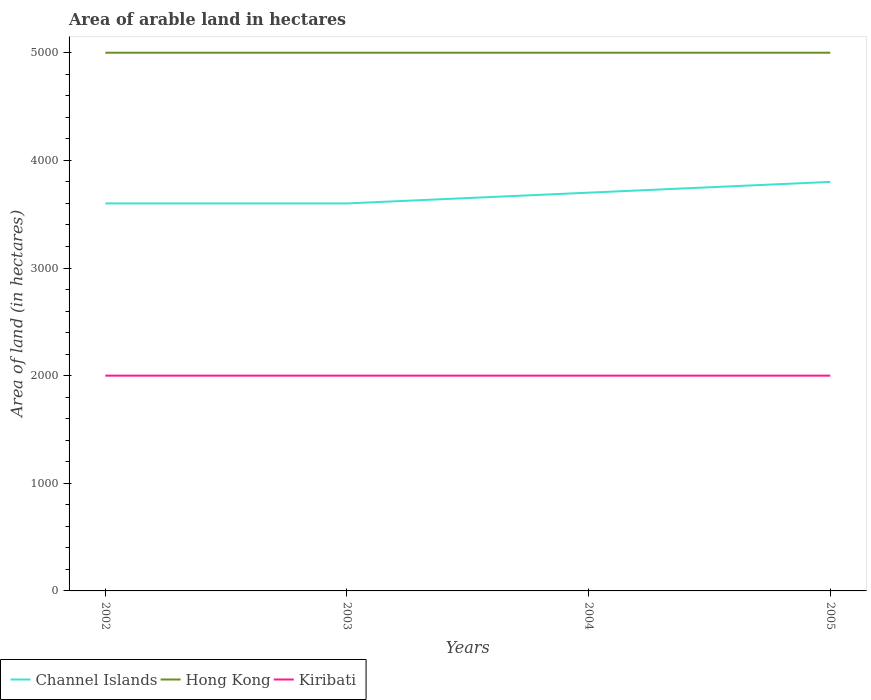Does the line corresponding to Hong Kong intersect with the line corresponding to Channel Islands?
Offer a terse response. No. Across all years, what is the maximum total arable land in Channel Islands?
Provide a short and direct response. 3600. In which year was the total arable land in Hong Kong maximum?
Your answer should be very brief. 2002. What is the total total arable land in Channel Islands in the graph?
Ensure brevity in your answer.  -100. What is the difference between the highest and the lowest total arable land in Channel Islands?
Make the answer very short. 2. What is the difference between two consecutive major ticks on the Y-axis?
Your response must be concise. 1000. How many legend labels are there?
Your answer should be compact. 3. What is the title of the graph?
Offer a terse response. Area of arable land in hectares. Does "Canada" appear as one of the legend labels in the graph?
Offer a terse response. No. What is the label or title of the X-axis?
Offer a very short reply. Years. What is the label or title of the Y-axis?
Ensure brevity in your answer.  Area of land (in hectares). What is the Area of land (in hectares) of Channel Islands in 2002?
Keep it short and to the point. 3600. What is the Area of land (in hectares) of Hong Kong in 2002?
Ensure brevity in your answer.  5000. What is the Area of land (in hectares) of Kiribati in 2002?
Provide a short and direct response. 2000. What is the Area of land (in hectares) of Channel Islands in 2003?
Keep it short and to the point. 3600. What is the Area of land (in hectares) in Hong Kong in 2003?
Your response must be concise. 5000. What is the Area of land (in hectares) of Kiribati in 2003?
Provide a succinct answer. 2000. What is the Area of land (in hectares) in Channel Islands in 2004?
Keep it short and to the point. 3700. What is the Area of land (in hectares) in Hong Kong in 2004?
Offer a very short reply. 5000. What is the Area of land (in hectares) in Kiribati in 2004?
Offer a terse response. 2000. What is the Area of land (in hectares) in Channel Islands in 2005?
Provide a short and direct response. 3800. Across all years, what is the maximum Area of land (in hectares) of Channel Islands?
Provide a short and direct response. 3800. Across all years, what is the maximum Area of land (in hectares) of Hong Kong?
Give a very brief answer. 5000. Across all years, what is the minimum Area of land (in hectares) in Channel Islands?
Offer a terse response. 3600. Across all years, what is the minimum Area of land (in hectares) in Kiribati?
Provide a short and direct response. 2000. What is the total Area of land (in hectares) in Channel Islands in the graph?
Keep it short and to the point. 1.47e+04. What is the total Area of land (in hectares) in Hong Kong in the graph?
Your response must be concise. 2.00e+04. What is the total Area of land (in hectares) of Kiribati in the graph?
Make the answer very short. 8000. What is the difference between the Area of land (in hectares) in Channel Islands in 2002 and that in 2004?
Your answer should be very brief. -100. What is the difference between the Area of land (in hectares) in Hong Kong in 2002 and that in 2004?
Provide a succinct answer. 0. What is the difference between the Area of land (in hectares) of Channel Islands in 2002 and that in 2005?
Provide a short and direct response. -200. What is the difference between the Area of land (in hectares) in Hong Kong in 2002 and that in 2005?
Give a very brief answer. 0. What is the difference between the Area of land (in hectares) of Kiribati in 2002 and that in 2005?
Your response must be concise. 0. What is the difference between the Area of land (in hectares) in Channel Islands in 2003 and that in 2004?
Your response must be concise. -100. What is the difference between the Area of land (in hectares) of Kiribati in 2003 and that in 2004?
Your response must be concise. 0. What is the difference between the Area of land (in hectares) in Channel Islands in 2003 and that in 2005?
Your answer should be compact. -200. What is the difference between the Area of land (in hectares) of Hong Kong in 2003 and that in 2005?
Offer a terse response. 0. What is the difference between the Area of land (in hectares) of Channel Islands in 2004 and that in 2005?
Your answer should be compact. -100. What is the difference between the Area of land (in hectares) of Channel Islands in 2002 and the Area of land (in hectares) of Hong Kong in 2003?
Offer a terse response. -1400. What is the difference between the Area of land (in hectares) of Channel Islands in 2002 and the Area of land (in hectares) of Kiribati in 2003?
Give a very brief answer. 1600. What is the difference between the Area of land (in hectares) in Hong Kong in 2002 and the Area of land (in hectares) in Kiribati in 2003?
Your answer should be very brief. 3000. What is the difference between the Area of land (in hectares) of Channel Islands in 2002 and the Area of land (in hectares) of Hong Kong in 2004?
Keep it short and to the point. -1400. What is the difference between the Area of land (in hectares) in Channel Islands in 2002 and the Area of land (in hectares) in Kiribati in 2004?
Provide a short and direct response. 1600. What is the difference between the Area of land (in hectares) of Hong Kong in 2002 and the Area of land (in hectares) of Kiribati in 2004?
Provide a succinct answer. 3000. What is the difference between the Area of land (in hectares) in Channel Islands in 2002 and the Area of land (in hectares) in Hong Kong in 2005?
Offer a terse response. -1400. What is the difference between the Area of land (in hectares) in Channel Islands in 2002 and the Area of land (in hectares) in Kiribati in 2005?
Provide a succinct answer. 1600. What is the difference between the Area of land (in hectares) in Hong Kong in 2002 and the Area of land (in hectares) in Kiribati in 2005?
Give a very brief answer. 3000. What is the difference between the Area of land (in hectares) of Channel Islands in 2003 and the Area of land (in hectares) of Hong Kong in 2004?
Your response must be concise. -1400. What is the difference between the Area of land (in hectares) in Channel Islands in 2003 and the Area of land (in hectares) in Kiribati in 2004?
Make the answer very short. 1600. What is the difference between the Area of land (in hectares) of Hong Kong in 2003 and the Area of land (in hectares) of Kiribati in 2004?
Your answer should be very brief. 3000. What is the difference between the Area of land (in hectares) of Channel Islands in 2003 and the Area of land (in hectares) of Hong Kong in 2005?
Provide a short and direct response. -1400. What is the difference between the Area of land (in hectares) of Channel Islands in 2003 and the Area of land (in hectares) of Kiribati in 2005?
Your answer should be compact. 1600. What is the difference between the Area of land (in hectares) of Hong Kong in 2003 and the Area of land (in hectares) of Kiribati in 2005?
Offer a terse response. 3000. What is the difference between the Area of land (in hectares) in Channel Islands in 2004 and the Area of land (in hectares) in Hong Kong in 2005?
Make the answer very short. -1300. What is the difference between the Area of land (in hectares) of Channel Islands in 2004 and the Area of land (in hectares) of Kiribati in 2005?
Offer a terse response. 1700. What is the difference between the Area of land (in hectares) of Hong Kong in 2004 and the Area of land (in hectares) of Kiribati in 2005?
Offer a terse response. 3000. What is the average Area of land (in hectares) of Channel Islands per year?
Provide a succinct answer. 3675. In the year 2002, what is the difference between the Area of land (in hectares) of Channel Islands and Area of land (in hectares) of Hong Kong?
Provide a succinct answer. -1400. In the year 2002, what is the difference between the Area of land (in hectares) of Channel Islands and Area of land (in hectares) of Kiribati?
Your answer should be compact. 1600. In the year 2002, what is the difference between the Area of land (in hectares) of Hong Kong and Area of land (in hectares) of Kiribati?
Give a very brief answer. 3000. In the year 2003, what is the difference between the Area of land (in hectares) in Channel Islands and Area of land (in hectares) in Hong Kong?
Ensure brevity in your answer.  -1400. In the year 2003, what is the difference between the Area of land (in hectares) of Channel Islands and Area of land (in hectares) of Kiribati?
Provide a succinct answer. 1600. In the year 2003, what is the difference between the Area of land (in hectares) in Hong Kong and Area of land (in hectares) in Kiribati?
Your answer should be very brief. 3000. In the year 2004, what is the difference between the Area of land (in hectares) of Channel Islands and Area of land (in hectares) of Hong Kong?
Provide a short and direct response. -1300. In the year 2004, what is the difference between the Area of land (in hectares) in Channel Islands and Area of land (in hectares) in Kiribati?
Keep it short and to the point. 1700. In the year 2004, what is the difference between the Area of land (in hectares) of Hong Kong and Area of land (in hectares) of Kiribati?
Keep it short and to the point. 3000. In the year 2005, what is the difference between the Area of land (in hectares) of Channel Islands and Area of land (in hectares) of Hong Kong?
Give a very brief answer. -1200. In the year 2005, what is the difference between the Area of land (in hectares) in Channel Islands and Area of land (in hectares) in Kiribati?
Your answer should be very brief. 1800. In the year 2005, what is the difference between the Area of land (in hectares) in Hong Kong and Area of land (in hectares) in Kiribati?
Your answer should be very brief. 3000. What is the ratio of the Area of land (in hectares) in Channel Islands in 2002 to that in 2003?
Make the answer very short. 1. What is the ratio of the Area of land (in hectares) of Hong Kong in 2002 to that in 2003?
Provide a short and direct response. 1. What is the ratio of the Area of land (in hectares) in Kiribati in 2002 to that in 2003?
Provide a short and direct response. 1. What is the ratio of the Area of land (in hectares) in Channel Islands in 2002 to that in 2004?
Ensure brevity in your answer.  0.97. What is the ratio of the Area of land (in hectares) of Hong Kong in 2002 to that in 2004?
Offer a terse response. 1. What is the ratio of the Area of land (in hectares) in Kiribati in 2002 to that in 2004?
Your answer should be very brief. 1. What is the ratio of the Area of land (in hectares) in Hong Kong in 2002 to that in 2005?
Give a very brief answer. 1. What is the ratio of the Area of land (in hectares) in Channel Islands in 2003 to that in 2004?
Your answer should be very brief. 0.97. What is the ratio of the Area of land (in hectares) in Hong Kong in 2003 to that in 2005?
Give a very brief answer. 1. What is the ratio of the Area of land (in hectares) of Channel Islands in 2004 to that in 2005?
Ensure brevity in your answer.  0.97. What is the ratio of the Area of land (in hectares) of Hong Kong in 2004 to that in 2005?
Make the answer very short. 1. What is the difference between the highest and the second highest Area of land (in hectares) of Kiribati?
Offer a very short reply. 0. What is the difference between the highest and the lowest Area of land (in hectares) in Hong Kong?
Provide a succinct answer. 0. 